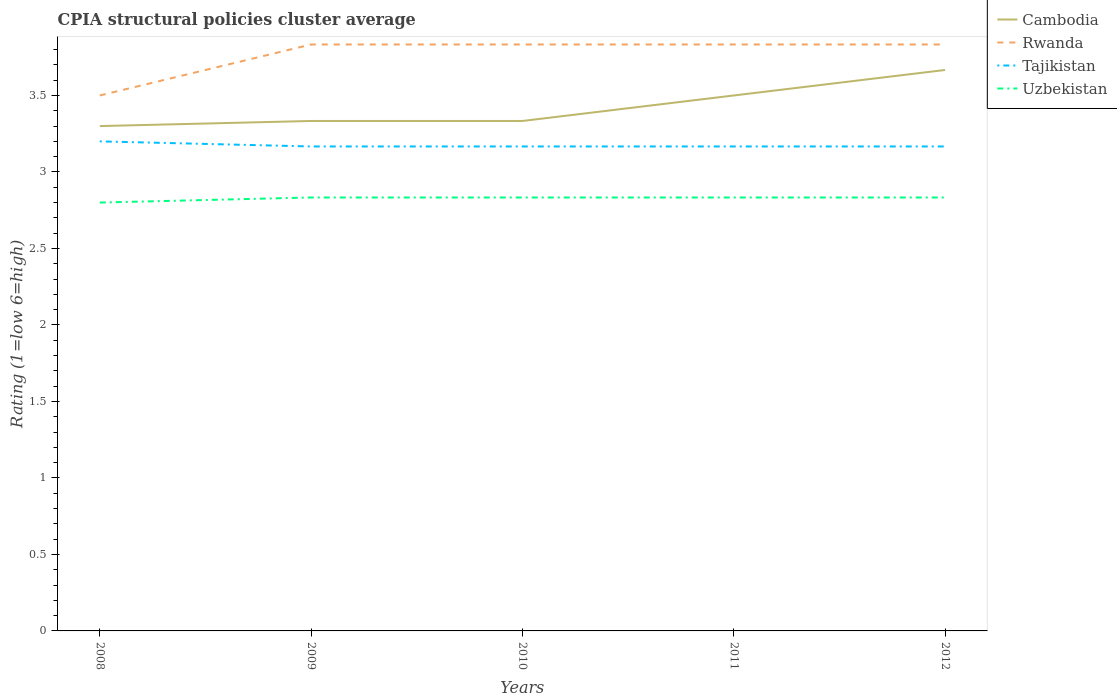How many different coloured lines are there?
Give a very brief answer. 4. Does the line corresponding to Uzbekistan intersect with the line corresponding to Tajikistan?
Keep it short and to the point. No. Across all years, what is the maximum CPIA rating in Rwanda?
Your response must be concise. 3.5. In which year was the CPIA rating in Cambodia maximum?
Keep it short and to the point. 2008. What is the total CPIA rating in Uzbekistan in the graph?
Give a very brief answer. -0.03. What is the difference between the highest and the second highest CPIA rating in Uzbekistan?
Your answer should be very brief. 0.03. What is the difference between the highest and the lowest CPIA rating in Rwanda?
Offer a very short reply. 4. Is the CPIA rating in Uzbekistan strictly greater than the CPIA rating in Cambodia over the years?
Give a very brief answer. Yes. How many years are there in the graph?
Give a very brief answer. 5. Does the graph contain any zero values?
Offer a terse response. No. How are the legend labels stacked?
Give a very brief answer. Vertical. What is the title of the graph?
Your answer should be very brief. CPIA structural policies cluster average. What is the label or title of the X-axis?
Offer a terse response. Years. What is the Rating (1=low 6=high) of Rwanda in 2008?
Your response must be concise. 3.5. What is the Rating (1=low 6=high) of Tajikistan in 2008?
Keep it short and to the point. 3.2. What is the Rating (1=low 6=high) of Uzbekistan in 2008?
Your response must be concise. 2.8. What is the Rating (1=low 6=high) in Cambodia in 2009?
Offer a terse response. 3.33. What is the Rating (1=low 6=high) in Rwanda in 2009?
Your answer should be very brief. 3.83. What is the Rating (1=low 6=high) in Tajikistan in 2009?
Keep it short and to the point. 3.17. What is the Rating (1=low 6=high) of Uzbekistan in 2009?
Offer a very short reply. 2.83. What is the Rating (1=low 6=high) of Cambodia in 2010?
Offer a terse response. 3.33. What is the Rating (1=low 6=high) of Rwanda in 2010?
Ensure brevity in your answer.  3.83. What is the Rating (1=low 6=high) of Tajikistan in 2010?
Your answer should be compact. 3.17. What is the Rating (1=low 6=high) of Uzbekistan in 2010?
Provide a short and direct response. 2.83. What is the Rating (1=low 6=high) of Cambodia in 2011?
Keep it short and to the point. 3.5. What is the Rating (1=low 6=high) of Rwanda in 2011?
Your response must be concise. 3.83. What is the Rating (1=low 6=high) in Tajikistan in 2011?
Offer a terse response. 3.17. What is the Rating (1=low 6=high) of Uzbekistan in 2011?
Provide a succinct answer. 2.83. What is the Rating (1=low 6=high) in Cambodia in 2012?
Provide a succinct answer. 3.67. What is the Rating (1=low 6=high) of Rwanda in 2012?
Give a very brief answer. 3.83. What is the Rating (1=low 6=high) of Tajikistan in 2012?
Make the answer very short. 3.17. What is the Rating (1=low 6=high) in Uzbekistan in 2012?
Your answer should be very brief. 2.83. Across all years, what is the maximum Rating (1=low 6=high) of Cambodia?
Keep it short and to the point. 3.67. Across all years, what is the maximum Rating (1=low 6=high) of Rwanda?
Ensure brevity in your answer.  3.83. Across all years, what is the maximum Rating (1=low 6=high) of Tajikistan?
Ensure brevity in your answer.  3.2. Across all years, what is the maximum Rating (1=low 6=high) in Uzbekistan?
Your answer should be very brief. 2.83. Across all years, what is the minimum Rating (1=low 6=high) of Cambodia?
Provide a succinct answer. 3.3. Across all years, what is the minimum Rating (1=low 6=high) in Tajikistan?
Your answer should be very brief. 3.17. Across all years, what is the minimum Rating (1=low 6=high) of Uzbekistan?
Ensure brevity in your answer.  2.8. What is the total Rating (1=low 6=high) of Cambodia in the graph?
Provide a succinct answer. 17.13. What is the total Rating (1=low 6=high) of Rwanda in the graph?
Ensure brevity in your answer.  18.83. What is the total Rating (1=low 6=high) in Tajikistan in the graph?
Keep it short and to the point. 15.87. What is the total Rating (1=low 6=high) of Uzbekistan in the graph?
Provide a succinct answer. 14.13. What is the difference between the Rating (1=low 6=high) in Cambodia in 2008 and that in 2009?
Provide a short and direct response. -0.03. What is the difference between the Rating (1=low 6=high) in Tajikistan in 2008 and that in 2009?
Your answer should be compact. 0.03. What is the difference between the Rating (1=low 6=high) in Uzbekistan in 2008 and that in 2009?
Your answer should be compact. -0.03. What is the difference between the Rating (1=low 6=high) of Cambodia in 2008 and that in 2010?
Make the answer very short. -0.03. What is the difference between the Rating (1=low 6=high) of Uzbekistan in 2008 and that in 2010?
Provide a short and direct response. -0.03. What is the difference between the Rating (1=low 6=high) of Uzbekistan in 2008 and that in 2011?
Your answer should be compact. -0.03. What is the difference between the Rating (1=low 6=high) of Cambodia in 2008 and that in 2012?
Your answer should be very brief. -0.37. What is the difference between the Rating (1=low 6=high) of Rwanda in 2008 and that in 2012?
Your response must be concise. -0.33. What is the difference between the Rating (1=low 6=high) in Uzbekistan in 2008 and that in 2012?
Give a very brief answer. -0.03. What is the difference between the Rating (1=low 6=high) in Cambodia in 2009 and that in 2010?
Provide a short and direct response. 0. What is the difference between the Rating (1=low 6=high) of Rwanda in 2009 and that in 2010?
Give a very brief answer. 0. What is the difference between the Rating (1=low 6=high) of Cambodia in 2009 and that in 2011?
Make the answer very short. -0.17. What is the difference between the Rating (1=low 6=high) in Rwanda in 2009 and that in 2011?
Your answer should be compact. 0. What is the difference between the Rating (1=low 6=high) of Tajikistan in 2009 and that in 2011?
Provide a succinct answer. 0. What is the difference between the Rating (1=low 6=high) of Rwanda in 2009 and that in 2012?
Give a very brief answer. 0. What is the difference between the Rating (1=low 6=high) of Cambodia in 2010 and that in 2011?
Your answer should be very brief. -0.17. What is the difference between the Rating (1=low 6=high) in Cambodia in 2010 and that in 2012?
Offer a terse response. -0.33. What is the difference between the Rating (1=low 6=high) in Rwanda in 2010 and that in 2012?
Your response must be concise. 0. What is the difference between the Rating (1=low 6=high) in Uzbekistan in 2010 and that in 2012?
Your answer should be very brief. 0. What is the difference between the Rating (1=low 6=high) in Cambodia in 2011 and that in 2012?
Your response must be concise. -0.17. What is the difference between the Rating (1=low 6=high) of Uzbekistan in 2011 and that in 2012?
Your response must be concise. 0. What is the difference between the Rating (1=low 6=high) in Cambodia in 2008 and the Rating (1=low 6=high) in Rwanda in 2009?
Keep it short and to the point. -0.53. What is the difference between the Rating (1=low 6=high) in Cambodia in 2008 and the Rating (1=low 6=high) in Tajikistan in 2009?
Your answer should be compact. 0.13. What is the difference between the Rating (1=low 6=high) in Cambodia in 2008 and the Rating (1=low 6=high) in Uzbekistan in 2009?
Your response must be concise. 0.47. What is the difference between the Rating (1=low 6=high) in Rwanda in 2008 and the Rating (1=low 6=high) in Uzbekistan in 2009?
Your answer should be very brief. 0.67. What is the difference between the Rating (1=low 6=high) of Tajikistan in 2008 and the Rating (1=low 6=high) of Uzbekistan in 2009?
Give a very brief answer. 0.37. What is the difference between the Rating (1=low 6=high) in Cambodia in 2008 and the Rating (1=low 6=high) in Rwanda in 2010?
Your answer should be very brief. -0.53. What is the difference between the Rating (1=low 6=high) in Cambodia in 2008 and the Rating (1=low 6=high) in Tajikistan in 2010?
Provide a short and direct response. 0.13. What is the difference between the Rating (1=low 6=high) in Cambodia in 2008 and the Rating (1=low 6=high) in Uzbekistan in 2010?
Ensure brevity in your answer.  0.47. What is the difference between the Rating (1=low 6=high) of Rwanda in 2008 and the Rating (1=low 6=high) of Uzbekistan in 2010?
Give a very brief answer. 0.67. What is the difference between the Rating (1=low 6=high) in Tajikistan in 2008 and the Rating (1=low 6=high) in Uzbekistan in 2010?
Keep it short and to the point. 0.37. What is the difference between the Rating (1=low 6=high) in Cambodia in 2008 and the Rating (1=low 6=high) in Rwanda in 2011?
Offer a very short reply. -0.53. What is the difference between the Rating (1=low 6=high) in Cambodia in 2008 and the Rating (1=low 6=high) in Tajikistan in 2011?
Offer a very short reply. 0.13. What is the difference between the Rating (1=low 6=high) of Cambodia in 2008 and the Rating (1=low 6=high) of Uzbekistan in 2011?
Keep it short and to the point. 0.47. What is the difference between the Rating (1=low 6=high) of Rwanda in 2008 and the Rating (1=low 6=high) of Uzbekistan in 2011?
Give a very brief answer. 0.67. What is the difference between the Rating (1=low 6=high) in Tajikistan in 2008 and the Rating (1=low 6=high) in Uzbekistan in 2011?
Give a very brief answer. 0.37. What is the difference between the Rating (1=low 6=high) in Cambodia in 2008 and the Rating (1=low 6=high) in Rwanda in 2012?
Your answer should be compact. -0.53. What is the difference between the Rating (1=low 6=high) in Cambodia in 2008 and the Rating (1=low 6=high) in Tajikistan in 2012?
Make the answer very short. 0.13. What is the difference between the Rating (1=low 6=high) in Cambodia in 2008 and the Rating (1=low 6=high) in Uzbekistan in 2012?
Your answer should be compact. 0.47. What is the difference between the Rating (1=low 6=high) of Tajikistan in 2008 and the Rating (1=low 6=high) of Uzbekistan in 2012?
Provide a short and direct response. 0.37. What is the difference between the Rating (1=low 6=high) in Cambodia in 2009 and the Rating (1=low 6=high) in Tajikistan in 2010?
Your answer should be compact. 0.17. What is the difference between the Rating (1=low 6=high) in Rwanda in 2009 and the Rating (1=low 6=high) in Tajikistan in 2010?
Provide a succinct answer. 0.67. What is the difference between the Rating (1=low 6=high) of Rwanda in 2009 and the Rating (1=low 6=high) of Uzbekistan in 2010?
Your answer should be very brief. 1. What is the difference between the Rating (1=low 6=high) in Cambodia in 2009 and the Rating (1=low 6=high) in Rwanda in 2011?
Your response must be concise. -0.5. What is the difference between the Rating (1=low 6=high) of Cambodia in 2009 and the Rating (1=low 6=high) of Uzbekistan in 2011?
Your answer should be very brief. 0.5. What is the difference between the Rating (1=low 6=high) in Rwanda in 2009 and the Rating (1=low 6=high) in Tajikistan in 2011?
Keep it short and to the point. 0.67. What is the difference between the Rating (1=low 6=high) of Tajikistan in 2009 and the Rating (1=low 6=high) of Uzbekistan in 2011?
Your answer should be very brief. 0.33. What is the difference between the Rating (1=low 6=high) in Cambodia in 2009 and the Rating (1=low 6=high) in Rwanda in 2012?
Ensure brevity in your answer.  -0.5. What is the difference between the Rating (1=low 6=high) of Cambodia in 2009 and the Rating (1=low 6=high) of Tajikistan in 2012?
Offer a very short reply. 0.17. What is the difference between the Rating (1=low 6=high) in Rwanda in 2009 and the Rating (1=low 6=high) in Uzbekistan in 2012?
Your response must be concise. 1. What is the difference between the Rating (1=low 6=high) in Cambodia in 2010 and the Rating (1=low 6=high) in Tajikistan in 2011?
Your response must be concise. 0.17. What is the difference between the Rating (1=low 6=high) of Rwanda in 2010 and the Rating (1=low 6=high) of Tajikistan in 2011?
Offer a very short reply. 0.67. What is the difference between the Rating (1=low 6=high) in Rwanda in 2010 and the Rating (1=low 6=high) in Uzbekistan in 2011?
Your answer should be compact. 1. What is the difference between the Rating (1=low 6=high) in Cambodia in 2010 and the Rating (1=low 6=high) in Tajikistan in 2012?
Your answer should be compact. 0.17. What is the difference between the Rating (1=low 6=high) in Cambodia in 2010 and the Rating (1=low 6=high) in Uzbekistan in 2012?
Keep it short and to the point. 0.5. What is the difference between the Rating (1=low 6=high) of Rwanda in 2010 and the Rating (1=low 6=high) of Uzbekistan in 2012?
Offer a terse response. 1. What is the difference between the Rating (1=low 6=high) of Tajikistan in 2010 and the Rating (1=low 6=high) of Uzbekistan in 2012?
Offer a terse response. 0.33. What is the difference between the Rating (1=low 6=high) of Cambodia in 2011 and the Rating (1=low 6=high) of Rwanda in 2012?
Give a very brief answer. -0.33. What is the difference between the Rating (1=low 6=high) in Rwanda in 2011 and the Rating (1=low 6=high) in Uzbekistan in 2012?
Offer a very short reply. 1. What is the difference between the Rating (1=low 6=high) in Tajikistan in 2011 and the Rating (1=low 6=high) in Uzbekistan in 2012?
Provide a short and direct response. 0.33. What is the average Rating (1=low 6=high) of Cambodia per year?
Your answer should be compact. 3.43. What is the average Rating (1=low 6=high) in Rwanda per year?
Give a very brief answer. 3.77. What is the average Rating (1=low 6=high) of Tajikistan per year?
Offer a terse response. 3.17. What is the average Rating (1=low 6=high) of Uzbekistan per year?
Your answer should be compact. 2.83. In the year 2008, what is the difference between the Rating (1=low 6=high) in Cambodia and Rating (1=low 6=high) in Uzbekistan?
Provide a short and direct response. 0.5. In the year 2008, what is the difference between the Rating (1=low 6=high) in Rwanda and Rating (1=low 6=high) in Uzbekistan?
Give a very brief answer. 0.7. In the year 2009, what is the difference between the Rating (1=low 6=high) of Cambodia and Rating (1=low 6=high) of Rwanda?
Provide a short and direct response. -0.5. In the year 2009, what is the difference between the Rating (1=low 6=high) in Cambodia and Rating (1=low 6=high) in Uzbekistan?
Make the answer very short. 0.5. In the year 2009, what is the difference between the Rating (1=low 6=high) in Rwanda and Rating (1=low 6=high) in Uzbekistan?
Provide a succinct answer. 1. In the year 2009, what is the difference between the Rating (1=low 6=high) in Tajikistan and Rating (1=low 6=high) in Uzbekistan?
Make the answer very short. 0.33. In the year 2010, what is the difference between the Rating (1=low 6=high) of Rwanda and Rating (1=low 6=high) of Tajikistan?
Give a very brief answer. 0.67. In the year 2010, what is the difference between the Rating (1=low 6=high) of Rwanda and Rating (1=low 6=high) of Uzbekistan?
Offer a very short reply. 1. In the year 2010, what is the difference between the Rating (1=low 6=high) in Tajikistan and Rating (1=low 6=high) in Uzbekistan?
Provide a short and direct response. 0.33. In the year 2011, what is the difference between the Rating (1=low 6=high) of Cambodia and Rating (1=low 6=high) of Rwanda?
Give a very brief answer. -0.33. In the year 2011, what is the difference between the Rating (1=low 6=high) in Cambodia and Rating (1=low 6=high) in Uzbekistan?
Ensure brevity in your answer.  0.67. In the year 2011, what is the difference between the Rating (1=low 6=high) in Rwanda and Rating (1=low 6=high) in Tajikistan?
Ensure brevity in your answer.  0.67. In the year 2011, what is the difference between the Rating (1=low 6=high) in Rwanda and Rating (1=low 6=high) in Uzbekistan?
Offer a very short reply. 1. In the year 2011, what is the difference between the Rating (1=low 6=high) in Tajikistan and Rating (1=low 6=high) in Uzbekistan?
Your answer should be very brief. 0.33. In the year 2012, what is the difference between the Rating (1=low 6=high) of Cambodia and Rating (1=low 6=high) of Rwanda?
Provide a succinct answer. -0.17. In the year 2012, what is the difference between the Rating (1=low 6=high) in Cambodia and Rating (1=low 6=high) in Tajikistan?
Provide a short and direct response. 0.5. In the year 2012, what is the difference between the Rating (1=low 6=high) in Cambodia and Rating (1=low 6=high) in Uzbekistan?
Make the answer very short. 0.83. In the year 2012, what is the difference between the Rating (1=low 6=high) of Tajikistan and Rating (1=low 6=high) of Uzbekistan?
Provide a succinct answer. 0.33. What is the ratio of the Rating (1=low 6=high) in Cambodia in 2008 to that in 2009?
Offer a terse response. 0.99. What is the ratio of the Rating (1=low 6=high) of Tajikistan in 2008 to that in 2009?
Keep it short and to the point. 1.01. What is the ratio of the Rating (1=low 6=high) of Uzbekistan in 2008 to that in 2009?
Ensure brevity in your answer.  0.99. What is the ratio of the Rating (1=low 6=high) of Tajikistan in 2008 to that in 2010?
Provide a succinct answer. 1.01. What is the ratio of the Rating (1=low 6=high) of Uzbekistan in 2008 to that in 2010?
Your answer should be very brief. 0.99. What is the ratio of the Rating (1=low 6=high) in Cambodia in 2008 to that in 2011?
Provide a succinct answer. 0.94. What is the ratio of the Rating (1=low 6=high) in Tajikistan in 2008 to that in 2011?
Provide a short and direct response. 1.01. What is the ratio of the Rating (1=low 6=high) of Uzbekistan in 2008 to that in 2011?
Your answer should be very brief. 0.99. What is the ratio of the Rating (1=low 6=high) of Tajikistan in 2008 to that in 2012?
Your response must be concise. 1.01. What is the ratio of the Rating (1=low 6=high) of Rwanda in 2009 to that in 2010?
Offer a very short reply. 1. What is the ratio of the Rating (1=low 6=high) of Tajikistan in 2009 to that in 2010?
Keep it short and to the point. 1. What is the ratio of the Rating (1=low 6=high) of Uzbekistan in 2009 to that in 2010?
Ensure brevity in your answer.  1. What is the ratio of the Rating (1=low 6=high) of Cambodia in 2009 to that in 2011?
Ensure brevity in your answer.  0.95. What is the ratio of the Rating (1=low 6=high) in Tajikistan in 2009 to that in 2011?
Offer a very short reply. 1. What is the ratio of the Rating (1=low 6=high) in Uzbekistan in 2009 to that in 2011?
Give a very brief answer. 1. What is the ratio of the Rating (1=low 6=high) of Rwanda in 2009 to that in 2012?
Keep it short and to the point. 1. What is the ratio of the Rating (1=low 6=high) of Uzbekistan in 2010 to that in 2011?
Give a very brief answer. 1. What is the ratio of the Rating (1=low 6=high) in Cambodia in 2010 to that in 2012?
Keep it short and to the point. 0.91. What is the ratio of the Rating (1=low 6=high) in Cambodia in 2011 to that in 2012?
Offer a terse response. 0.95. What is the ratio of the Rating (1=low 6=high) in Rwanda in 2011 to that in 2012?
Your answer should be very brief. 1. What is the ratio of the Rating (1=low 6=high) of Uzbekistan in 2011 to that in 2012?
Your answer should be compact. 1. What is the difference between the highest and the second highest Rating (1=low 6=high) of Cambodia?
Provide a short and direct response. 0.17. What is the difference between the highest and the second highest Rating (1=low 6=high) in Rwanda?
Offer a very short reply. 0. What is the difference between the highest and the lowest Rating (1=low 6=high) of Cambodia?
Ensure brevity in your answer.  0.37. What is the difference between the highest and the lowest Rating (1=low 6=high) of Rwanda?
Your response must be concise. 0.33. What is the difference between the highest and the lowest Rating (1=low 6=high) in Uzbekistan?
Your answer should be very brief. 0.03. 